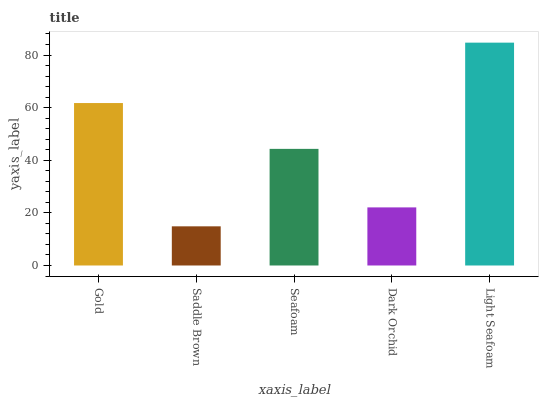Is Saddle Brown the minimum?
Answer yes or no. Yes. Is Light Seafoam the maximum?
Answer yes or no. Yes. Is Seafoam the minimum?
Answer yes or no. No. Is Seafoam the maximum?
Answer yes or no. No. Is Seafoam greater than Saddle Brown?
Answer yes or no. Yes. Is Saddle Brown less than Seafoam?
Answer yes or no. Yes. Is Saddle Brown greater than Seafoam?
Answer yes or no. No. Is Seafoam less than Saddle Brown?
Answer yes or no. No. Is Seafoam the high median?
Answer yes or no. Yes. Is Seafoam the low median?
Answer yes or no. Yes. Is Saddle Brown the high median?
Answer yes or no. No. Is Dark Orchid the low median?
Answer yes or no. No. 